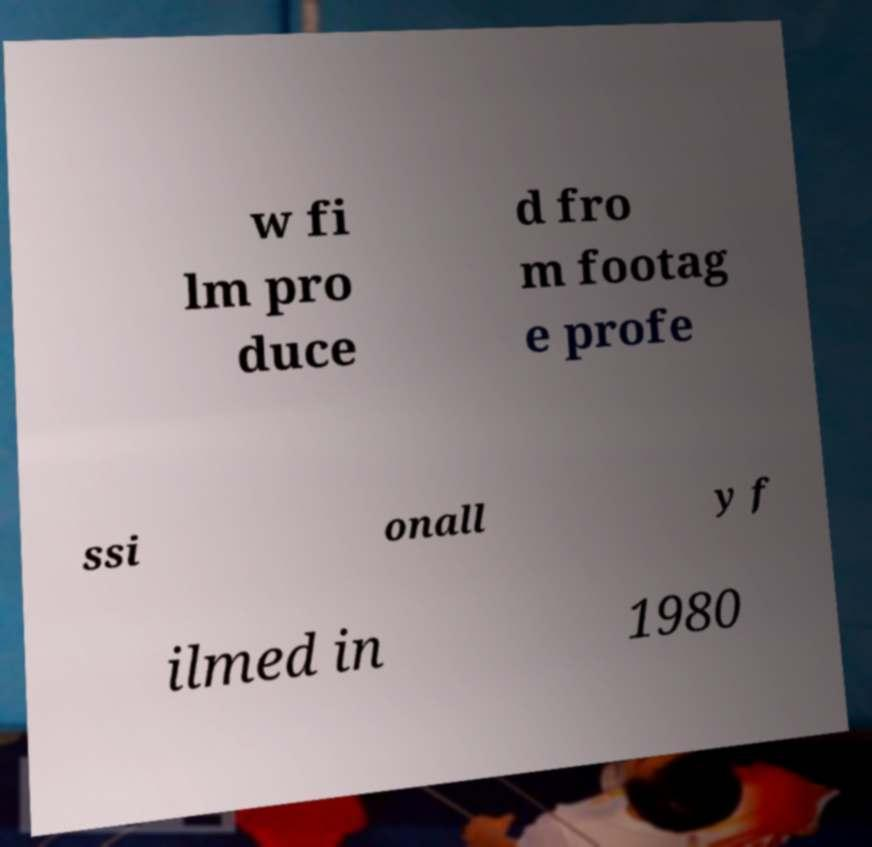Could you assist in decoding the text presented in this image and type it out clearly? w fi lm pro duce d fro m footag e profe ssi onall y f ilmed in 1980 